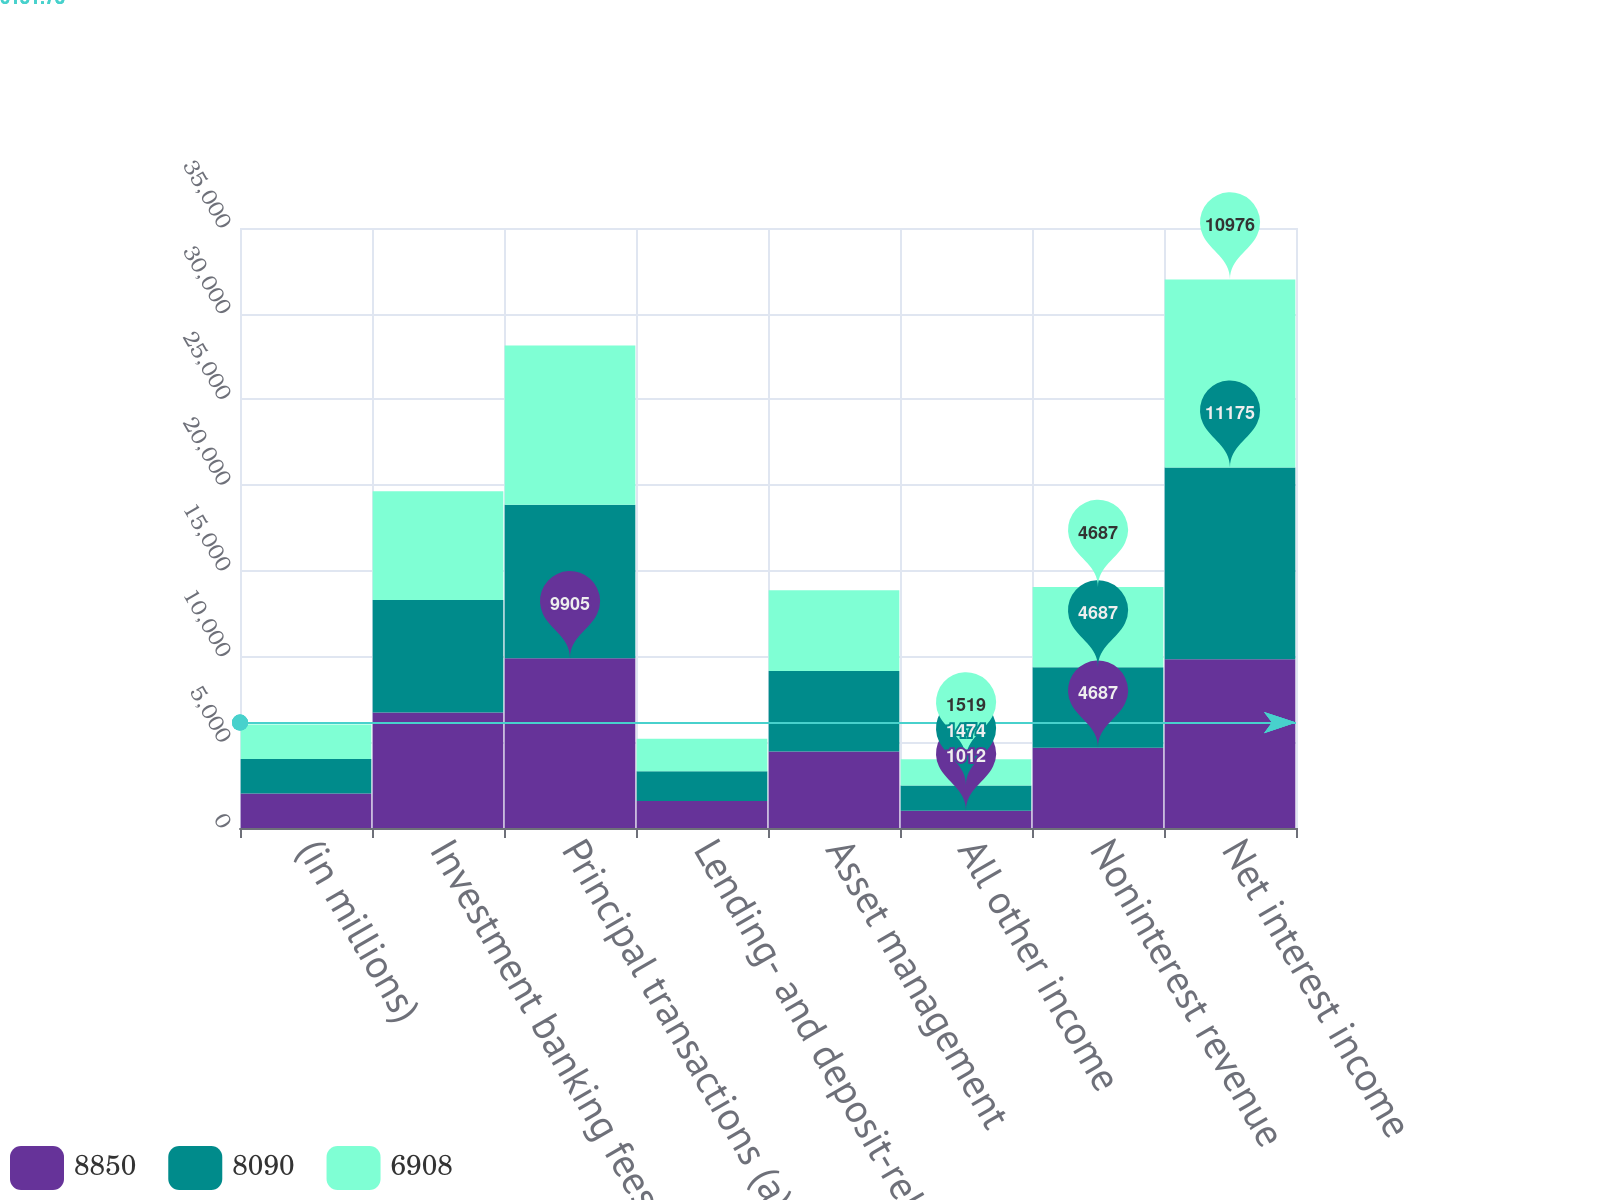<chart> <loc_0><loc_0><loc_500><loc_500><stacked_bar_chart><ecel><fcel>(in millions)<fcel>Investment banking fees<fcel>Principal transactions (a)<fcel>Lending- and deposit-related<fcel>Asset management<fcel>All other income<fcel>Noninterest revenue<fcel>Net interest income<nl><fcel>8850<fcel>2015<fcel>6736<fcel>9905<fcel>1573<fcel>4467<fcel>1012<fcel>4687<fcel>9849<nl><fcel>8090<fcel>2014<fcel>6570<fcel>8947<fcel>1742<fcel>4687<fcel>1474<fcel>4687<fcel>11175<nl><fcel>6908<fcel>2013<fcel>6331<fcel>9289<fcel>1884<fcel>4713<fcel>1519<fcel>4687<fcel>10976<nl></chart> 